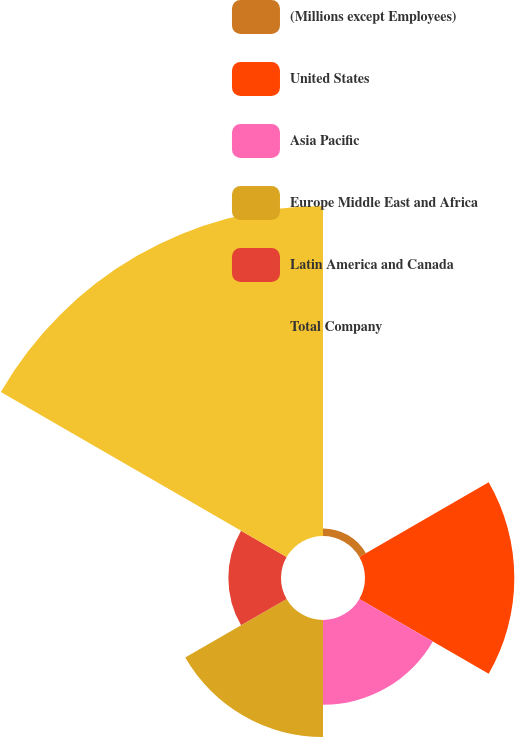Convert chart to OTSL. <chart><loc_0><loc_0><loc_500><loc_500><pie_chart><fcel>(Millions except Employees)<fcel>United States<fcel>Asia Pacific<fcel>Europe Middle East and Africa<fcel>Latin America and Canada<fcel>Total Company<nl><fcel>1.02%<fcel>20.14%<fcel>11.44%<fcel>15.79%<fcel>7.1%<fcel>44.51%<nl></chart> 